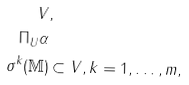<formula> <loc_0><loc_0><loc_500><loc_500>V & , \\ \Pi _ { U } \alpha & \\ \sigma ^ { k } ( \mathbb { M } ) & \subset V , k = 1 , \dots , m ,</formula> 